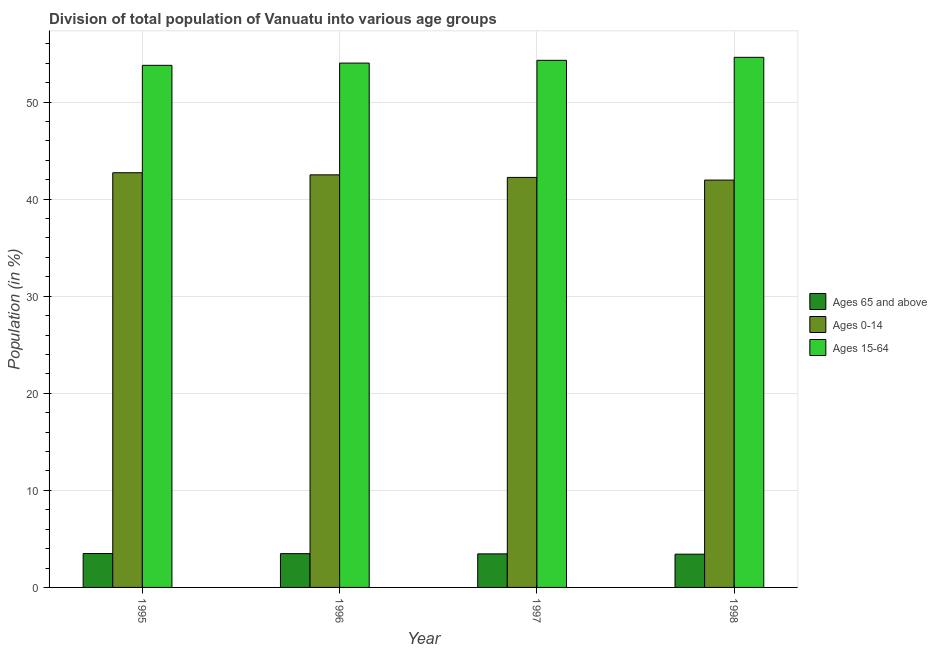How many groups of bars are there?
Give a very brief answer. 4. How many bars are there on the 3rd tick from the left?
Ensure brevity in your answer.  3. How many bars are there on the 4th tick from the right?
Your answer should be compact. 3. In how many cases, is the number of bars for a given year not equal to the number of legend labels?
Provide a short and direct response. 0. What is the percentage of population within the age-group 0-14 in 1996?
Offer a terse response. 42.5. Across all years, what is the maximum percentage of population within the age-group of 65 and above?
Ensure brevity in your answer.  3.49. Across all years, what is the minimum percentage of population within the age-group 0-14?
Provide a short and direct response. 41.96. What is the total percentage of population within the age-group 0-14 in the graph?
Offer a very short reply. 169.43. What is the difference between the percentage of population within the age-group 0-14 in 1995 and that in 1998?
Make the answer very short. 0.76. What is the difference between the percentage of population within the age-group of 65 and above in 1997 and the percentage of population within the age-group 0-14 in 1998?
Make the answer very short. 0.03. What is the average percentage of population within the age-group 15-64 per year?
Your answer should be compact. 54.18. In the year 1995, what is the difference between the percentage of population within the age-group 0-14 and percentage of population within the age-group of 65 and above?
Ensure brevity in your answer.  0. In how many years, is the percentage of population within the age-group 0-14 greater than 24 %?
Your response must be concise. 4. What is the ratio of the percentage of population within the age-group 15-64 in 1996 to that in 1997?
Offer a very short reply. 0.99. Is the percentage of population within the age-group 0-14 in 1996 less than that in 1998?
Offer a terse response. No. Is the difference between the percentage of population within the age-group of 65 and above in 1995 and 1998 greater than the difference between the percentage of population within the age-group 15-64 in 1995 and 1998?
Provide a short and direct response. No. What is the difference between the highest and the second highest percentage of population within the age-group 15-64?
Provide a short and direct response. 0.31. What is the difference between the highest and the lowest percentage of population within the age-group 15-64?
Offer a very short reply. 0.83. What does the 2nd bar from the left in 1998 represents?
Offer a very short reply. Ages 0-14. What does the 3rd bar from the right in 1997 represents?
Ensure brevity in your answer.  Ages 65 and above. How many bars are there?
Offer a very short reply. 12. Are the values on the major ticks of Y-axis written in scientific E-notation?
Your answer should be very brief. No. Does the graph contain any zero values?
Ensure brevity in your answer.  No. Where does the legend appear in the graph?
Offer a terse response. Center right. How are the legend labels stacked?
Offer a terse response. Vertical. What is the title of the graph?
Your answer should be very brief. Division of total population of Vanuatu into various age groups
. Does "Textiles and clothing" appear as one of the legend labels in the graph?
Offer a terse response. No. What is the label or title of the X-axis?
Provide a succinct answer. Year. What is the label or title of the Y-axis?
Give a very brief answer. Population (in %). What is the Population (in %) of Ages 65 and above in 1995?
Offer a terse response. 3.49. What is the Population (in %) in Ages 0-14 in 1995?
Provide a succinct answer. 42.72. What is the Population (in %) of Ages 15-64 in 1995?
Keep it short and to the point. 53.79. What is the Population (in %) in Ages 65 and above in 1996?
Ensure brevity in your answer.  3.48. What is the Population (in %) in Ages 0-14 in 1996?
Ensure brevity in your answer.  42.5. What is the Population (in %) in Ages 15-64 in 1996?
Provide a short and direct response. 54.02. What is the Population (in %) in Ages 65 and above in 1997?
Keep it short and to the point. 3.46. What is the Population (in %) in Ages 0-14 in 1997?
Offer a very short reply. 42.24. What is the Population (in %) in Ages 15-64 in 1997?
Your answer should be very brief. 54.3. What is the Population (in %) of Ages 65 and above in 1998?
Keep it short and to the point. 3.43. What is the Population (in %) of Ages 0-14 in 1998?
Offer a terse response. 41.96. What is the Population (in %) of Ages 15-64 in 1998?
Provide a short and direct response. 54.61. Across all years, what is the maximum Population (in %) in Ages 65 and above?
Provide a short and direct response. 3.49. Across all years, what is the maximum Population (in %) in Ages 0-14?
Your answer should be very brief. 42.72. Across all years, what is the maximum Population (in %) of Ages 15-64?
Offer a very short reply. 54.61. Across all years, what is the minimum Population (in %) in Ages 65 and above?
Offer a terse response. 3.43. Across all years, what is the minimum Population (in %) in Ages 0-14?
Make the answer very short. 41.96. Across all years, what is the minimum Population (in %) of Ages 15-64?
Provide a short and direct response. 53.79. What is the total Population (in %) in Ages 65 and above in the graph?
Make the answer very short. 13.86. What is the total Population (in %) of Ages 0-14 in the graph?
Make the answer very short. 169.43. What is the total Population (in %) in Ages 15-64 in the graph?
Offer a very short reply. 216.72. What is the difference between the Population (in %) of Ages 65 and above in 1995 and that in 1996?
Give a very brief answer. 0.01. What is the difference between the Population (in %) of Ages 0-14 in 1995 and that in 1996?
Your response must be concise. 0.22. What is the difference between the Population (in %) of Ages 15-64 in 1995 and that in 1996?
Offer a very short reply. -0.23. What is the difference between the Population (in %) in Ages 65 and above in 1995 and that in 1997?
Ensure brevity in your answer.  0.04. What is the difference between the Population (in %) in Ages 0-14 in 1995 and that in 1997?
Your answer should be very brief. 0.48. What is the difference between the Population (in %) in Ages 15-64 in 1995 and that in 1997?
Ensure brevity in your answer.  -0.52. What is the difference between the Population (in %) in Ages 65 and above in 1995 and that in 1998?
Your answer should be very brief. 0.07. What is the difference between the Population (in %) in Ages 0-14 in 1995 and that in 1998?
Make the answer very short. 0.76. What is the difference between the Population (in %) in Ages 15-64 in 1995 and that in 1998?
Ensure brevity in your answer.  -0.83. What is the difference between the Population (in %) in Ages 65 and above in 1996 and that in 1997?
Offer a terse response. 0.02. What is the difference between the Population (in %) of Ages 0-14 in 1996 and that in 1997?
Make the answer very short. 0.26. What is the difference between the Population (in %) of Ages 15-64 in 1996 and that in 1997?
Ensure brevity in your answer.  -0.29. What is the difference between the Population (in %) of Ages 65 and above in 1996 and that in 1998?
Provide a succinct answer. 0.05. What is the difference between the Population (in %) in Ages 0-14 in 1996 and that in 1998?
Your answer should be very brief. 0.54. What is the difference between the Population (in %) in Ages 15-64 in 1996 and that in 1998?
Provide a succinct answer. -0.59. What is the difference between the Population (in %) in Ages 65 and above in 1997 and that in 1998?
Give a very brief answer. 0.03. What is the difference between the Population (in %) in Ages 0-14 in 1997 and that in 1998?
Ensure brevity in your answer.  0.28. What is the difference between the Population (in %) in Ages 15-64 in 1997 and that in 1998?
Provide a short and direct response. -0.31. What is the difference between the Population (in %) of Ages 65 and above in 1995 and the Population (in %) of Ages 0-14 in 1996?
Ensure brevity in your answer.  -39.01. What is the difference between the Population (in %) of Ages 65 and above in 1995 and the Population (in %) of Ages 15-64 in 1996?
Your answer should be compact. -50.52. What is the difference between the Population (in %) of Ages 0-14 in 1995 and the Population (in %) of Ages 15-64 in 1996?
Offer a very short reply. -11.29. What is the difference between the Population (in %) of Ages 65 and above in 1995 and the Population (in %) of Ages 0-14 in 1997?
Give a very brief answer. -38.75. What is the difference between the Population (in %) in Ages 65 and above in 1995 and the Population (in %) in Ages 15-64 in 1997?
Make the answer very short. -50.81. What is the difference between the Population (in %) in Ages 0-14 in 1995 and the Population (in %) in Ages 15-64 in 1997?
Ensure brevity in your answer.  -11.58. What is the difference between the Population (in %) in Ages 65 and above in 1995 and the Population (in %) in Ages 0-14 in 1998?
Your answer should be compact. -38.47. What is the difference between the Population (in %) of Ages 65 and above in 1995 and the Population (in %) of Ages 15-64 in 1998?
Make the answer very short. -51.12. What is the difference between the Population (in %) of Ages 0-14 in 1995 and the Population (in %) of Ages 15-64 in 1998?
Your answer should be very brief. -11.89. What is the difference between the Population (in %) of Ages 65 and above in 1996 and the Population (in %) of Ages 0-14 in 1997?
Your answer should be compact. -38.76. What is the difference between the Population (in %) of Ages 65 and above in 1996 and the Population (in %) of Ages 15-64 in 1997?
Your response must be concise. -50.82. What is the difference between the Population (in %) in Ages 0-14 in 1996 and the Population (in %) in Ages 15-64 in 1997?
Provide a succinct answer. -11.8. What is the difference between the Population (in %) of Ages 65 and above in 1996 and the Population (in %) of Ages 0-14 in 1998?
Provide a short and direct response. -38.48. What is the difference between the Population (in %) in Ages 65 and above in 1996 and the Population (in %) in Ages 15-64 in 1998?
Give a very brief answer. -51.13. What is the difference between the Population (in %) of Ages 0-14 in 1996 and the Population (in %) of Ages 15-64 in 1998?
Ensure brevity in your answer.  -12.11. What is the difference between the Population (in %) in Ages 65 and above in 1997 and the Population (in %) in Ages 0-14 in 1998?
Offer a terse response. -38.51. What is the difference between the Population (in %) in Ages 65 and above in 1997 and the Population (in %) in Ages 15-64 in 1998?
Your response must be concise. -51.15. What is the difference between the Population (in %) of Ages 0-14 in 1997 and the Population (in %) of Ages 15-64 in 1998?
Provide a succinct answer. -12.37. What is the average Population (in %) of Ages 65 and above per year?
Make the answer very short. 3.46. What is the average Population (in %) of Ages 0-14 per year?
Give a very brief answer. 42.36. What is the average Population (in %) of Ages 15-64 per year?
Your answer should be very brief. 54.18. In the year 1995, what is the difference between the Population (in %) of Ages 65 and above and Population (in %) of Ages 0-14?
Your answer should be compact. -39.23. In the year 1995, what is the difference between the Population (in %) of Ages 65 and above and Population (in %) of Ages 15-64?
Your answer should be compact. -50.29. In the year 1995, what is the difference between the Population (in %) in Ages 0-14 and Population (in %) in Ages 15-64?
Offer a terse response. -11.06. In the year 1996, what is the difference between the Population (in %) in Ages 65 and above and Population (in %) in Ages 0-14?
Provide a succinct answer. -39.02. In the year 1996, what is the difference between the Population (in %) of Ages 65 and above and Population (in %) of Ages 15-64?
Offer a terse response. -50.54. In the year 1996, what is the difference between the Population (in %) of Ages 0-14 and Population (in %) of Ages 15-64?
Give a very brief answer. -11.51. In the year 1997, what is the difference between the Population (in %) of Ages 65 and above and Population (in %) of Ages 0-14?
Your response must be concise. -38.78. In the year 1997, what is the difference between the Population (in %) in Ages 65 and above and Population (in %) in Ages 15-64?
Provide a short and direct response. -50.85. In the year 1997, what is the difference between the Population (in %) of Ages 0-14 and Population (in %) of Ages 15-64?
Your answer should be very brief. -12.06. In the year 1998, what is the difference between the Population (in %) of Ages 65 and above and Population (in %) of Ages 0-14?
Offer a terse response. -38.54. In the year 1998, what is the difference between the Population (in %) of Ages 65 and above and Population (in %) of Ages 15-64?
Offer a very short reply. -51.18. In the year 1998, what is the difference between the Population (in %) of Ages 0-14 and Population (in %) of Ages 15-64?
Keep it short and to the point. -12.65. What is the ratio of the Population (in %) of Ages 65 and above in 1995 to that in 1996?
Make the answer very short. 1. What is the ratio of the Population (in %) of Ages 65 and above in 1995 to that in 1997?
Provide a succinct answer. 1.01. What is the ratio of the Population (in %) in Ages 0-14 in 1995 to that in 1997?
Offer a very short reply. 1.01. What is the ratio of the Population (in %) in Ages 65 and above in 1995 to that in 1998?
Your response must be concise. 1.02. What is the ratio of the Population (in %) in Ages 0-14 in 1995 to that in 1998?
Make the answer very short. 1.02. What is the ratio of the Population (in %) in Ages 15-64 in 1995 to that in 1998?
Make the answer very short. 0.98. What is the ratio of the Population (in %) of Ages 65 and above in 1996 to that in 1998?
Offer a very short reply. 1.02. What is the ratio of the Population (in %) of Ages 0-14 in 1996 to that in 1998?
Your answer should be compact. 1.01. What is the ratio of the Population (in %) of Ages 15-64 in 1996 to that in 1998?
Make the answer very short. 0.99. What is the ratio of the Population (in %) in Ages 65 and above in 1997 to that in 1998?
Keep it short and to the point. 1.01. What is the ratio of the Population (in %) of Ages 0-14 in 1997 to that in 1998?
Keep it short and to the point. 1.01. What is the ratio of the Population (in %) in Ages 15-64 in 1997 to that in 1998?
Give a very brief answer. 0.99. What is the difference between the highest and the second highest Population (in %) in Ages 65 and above?
Keep it short and to the point. 0.01. What is the difference between the highest and the second highest Population (in %) of Ages 0-14?
Your response must be concise. 0.22. What is the difference between the highest and the second highest Population (in %) of Ages 15-64?
Make the answer very short. 0.31. What is the difference between the highest and the lowest Population (in %) in Ages 65 and above?
Your answer should be compact. 0.07. What is the difference between the highest and the lowest Population (in %) in Ages 0-14?
Offer a very short reply. 0.76. What is the difference between the highest and the lowest Population (in %) of Ages 15-64?
Your answer should be compact. 0.83. 